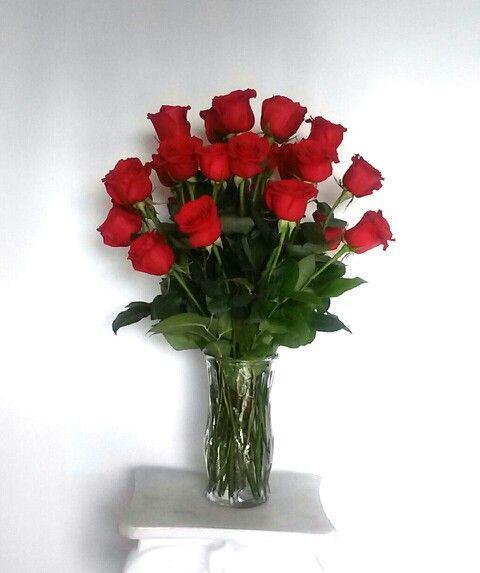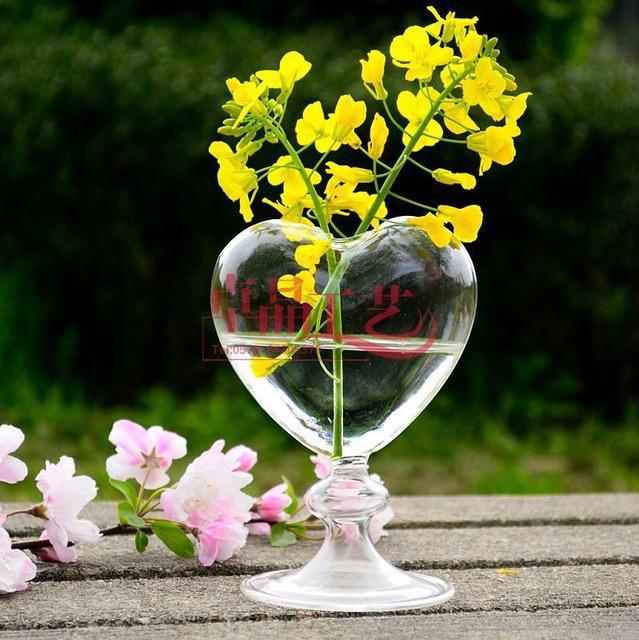The first image is the image on the left, the second image is the image on the right. Assess this claim about the two images: "There are three flowers in a small vase.". Correct or not? Answer yes or no. No. The first image is the image on the left, the second image is the image on the right. Considering the images on both sides, is "there are roses in a clear glass vase that is the same width on the bottom as it is on the top" valid? Answer yes or no. Yes. 